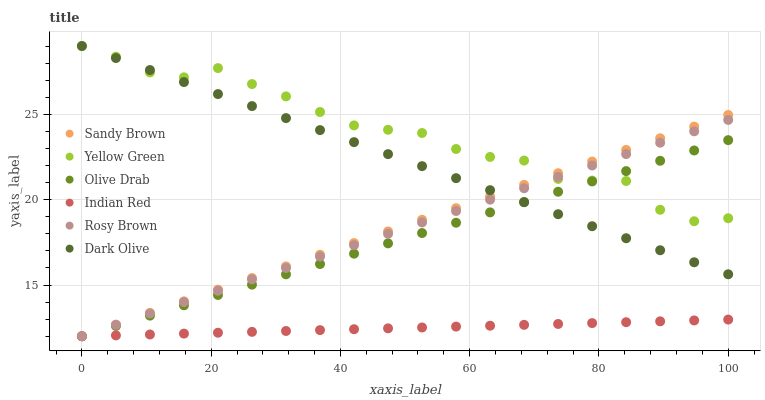Does Indian Red have the minimum area under the curve?
Answer yes or no. Yes. Does Yellow Green have the maximum area under the curve?
Answer yes or no. Yes. Does Dark Olive have the minimum area under the curve?
Answer yes or no. No. Does Dark Olive have the maximum area under the curve?
Answer yes or no. No. Is Dark Olive the smoothest?
Answer yes or no. Yes. Is Yellow Green the roughest?
Answer yes or no. Yes. Is Yellow Green the smoothest?
Answer yes or no. No. Is Dark Olive the roughest?
Answer yes or no. No. Does Rosy Brown have the lowest value?
Answer yes or no. Yes. Does Dark Olive have the lowest value?
Answer yes or no. No. Does Dark Olive have the highest value?
Answer yes or no. Yes. Does Indian Red have the highest value?
Answer yes or no. No. Is Indian Red less than Dark Olive?
Answer yes or no. Yes. Is Dark Olive greater than Indian Red?
Answer yes or no. Yes. Does Olive Drab intersect Dark Olive?
Answer yes or no. Yes. Is Olive Drab less than Dark Olive?
Answer yes or no. No. Is Olive Drab greater than Dark Olive?
Answer yes or no. No. Does Indian Red intersect Dark Olive?
Answer yes or no. No. 